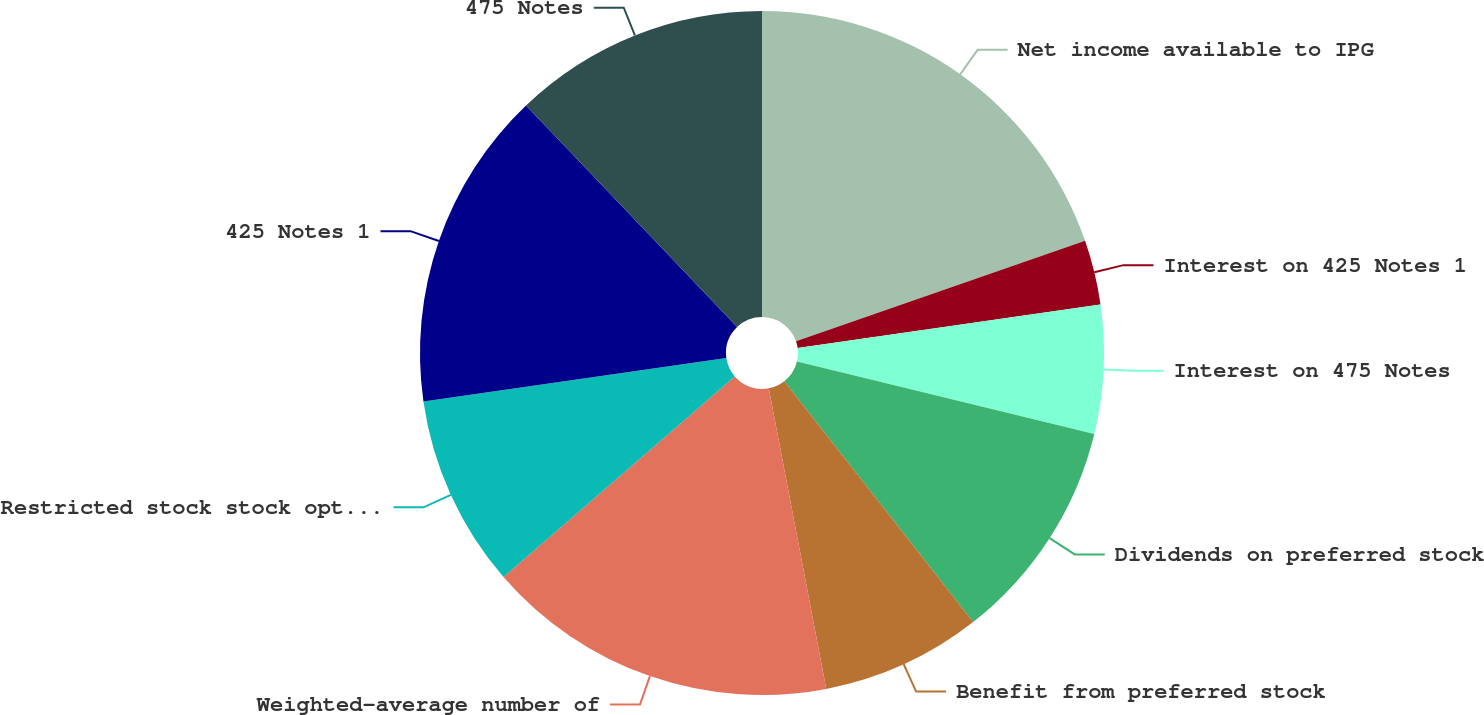<chart> <loc_0><loc_0><loc_500><loc_500><pie_chart><fcel>Net income available to IPG<fcel>Interest on 425 Notes 1<fcel>Interest on 475 Notes<fcel>Dividends on preferred stock<fcel>Benefit from preferred stock<fcel>Weighted-average number of<fcel>Restricted stock stock options<fcel>425 Notes 1<fcel>475 Notes<nl><fcel>19.68%<fcel>3.05%<fcel>6.07%<fcel>10.61%<fcel>7.58%<fcel>16.65%<fcel>9.1%<fcel>15.14%<fcel>12.12%<nl></chart> 